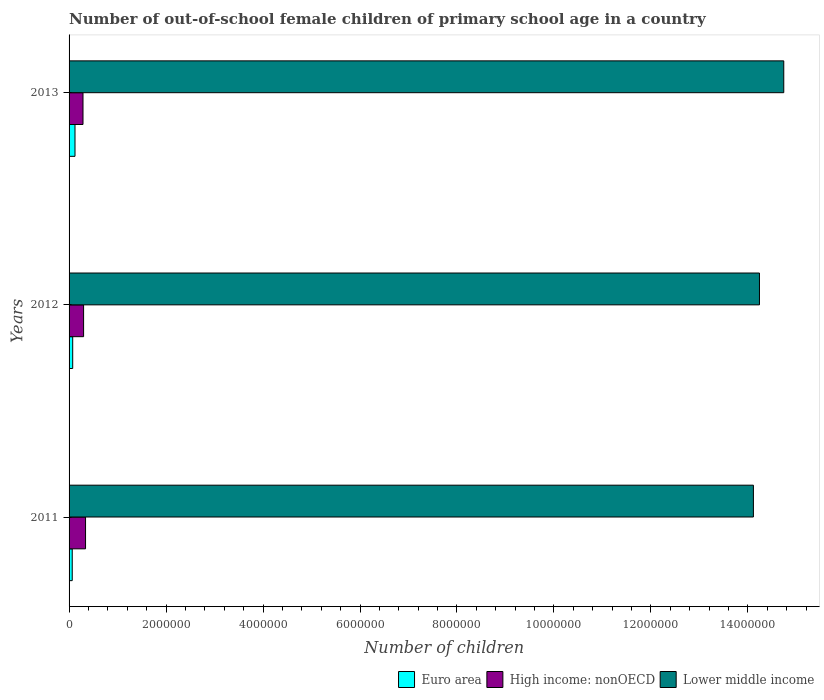How many different coloured bars are there?
Keep it short and to the point. 3. Are the number of bars per tick equal to the number of legend labels?
Your answer should be very brief. Yes. Are the number of bars on each tick of the Y-axis equal?
Ensure brevity in your answer.  Yes. How many bars are there on the 3rd tick from the top?
Your answer should be compact. 3. How many bars are there on the 3rd tick from the bottom?
Ensure brevity in your answer.  3. In how many cases, is the number of bars for a given year not equal to the number of legend labels?
Ensure brevity in your answer.  0. What is the number of out-of-school female children in Lower middle income in 2011?
Ensure brevity in your answer.  1.41e+07. Across all years, what is the maximum number of out-of-school female children in High income: nonOECD?
Your answer should be very brief. 3.40e+05. Across all years, what is the minimum number of out-of-school female children in Lower middle income?
Give a very brief answer. 1.41e+07. In which year was the number of out-of-school female children in Euro area minimum?
Provide a short and direct response. 2011. What is the total number of out-of-school female children in High income: nonOECD in the graph?
Offer a very short reply. 9.27e+05. What is the difference between the number of out-of-school female children in Lower middle income in 2011 and that in 2012?
Your response must be concise. -1.25e+05. What is the difference between the number of out-of-school female children in Euro area in 2011 and the number of out-of-school female children in High income: nonOECD in 2012?
Your response must be concise. -2.35e+05. What is the average number of out-of-school female children in High income: nonOECD per year?
Offer a very short reply. 3.09e+05. In the year 2012, what is the difference between the number of out-of-school female children in Euro area and number of out-of-school female children in Lower middle income?
Offer a very short reply. -1.42e+07. In how many years, is the number of out-of-school female children in Lower middle income greater than 6400000 ?
Make the answer very short. 3. What is the ratio of the number of out-of-school female children in Lower middle income in 2011 to that in 2012?
Offer a terse response. 0.99. Is the number of out-of-school female children in High income: nonOECD in 2011 less than that in 2012?
Offer a very short reply. No. Is the difference between the number of out-of-school female children in Euro area in 2012 and 2013 greater than the difference between the number of out-of-school female children in Lower middle income in 2012 and 2013?
Give a very brief answer. Yes. What is the difference between the highest and the second highest number of out-of-school female children in Lower middle income?
Your response must be concise. 5.01e+05. What is the difference between the highest and the lowest number of out-of-school female children in Lower middle income?
Your response must be concise. 6.26e+05. In how many years, is the number of out-of-school female children in Lower middle income greater than the average number of out-of-school female children in Lower middle income taken over all years?
Your response must be concise. 1. What does the 1st bar from the top in 2013 represents?
Keep it short and to the point. Lower middle income. What does the 1st bar from the bottom in 2012 represents?
Provide a succinct answer. Euro area. Is it the case that in every year, the sum of the number of out-of-school female children in High income: nonOECD and number of out-of-school female children in Euro area is greater than the number of out-of-school female children in Lower middle income?
Ensure brevity in your answer.  No. How many bars are there?
Your answer should be compact. 9. Are all the bars in the graph horizontal?
Provide a short and direct response. Yes. How many years are there in the graph?
Keep it short and to the point. 3. What is the difference between two consecutive major ticks on the X-axis?
Offer a very short reply. 2.00e+06. Does the graph contain any zero values?
Ensure brevity in your answer.  No. Does the graph contain grids?
Make the answer very short. No. How many legend labels are there?
Make the answer very short. 3. What is the title of the graph?
Give a very brief answer. Number of out-of-school female children of primary school age in a country. Does "Sweden" appear as one of the legend labels in the graph?
Offer a very short reply. No. What is the label or title of the X-axis?
Offer a terse response. Number of children. What is the Number of children in Euro area in 2011?
Offer a terse response. 6.51e+04. What is the Number of children of High income: nonOECD in 2011?
Provide a short and direct response. 3.40e+05. What is the Number of children in Lower middle income in 2011?
Your response must be concise. 1.41e+07. What is the Number of children of Euro area in 2012?
Your response must be concise. 7.48e+04. What is the Number of children in High income: nonOECD in 2012?
Provide a short and direct response. 3.00e+05. What is the Number of children in Lower middle income in 2012?
Offer a very short reply. 1.42e+07. What is the Number of children in Euro area in 2013?
Give a very brief answer. 1.22e+05. What is the Number of children of High income: nonOECD in 2013?
Ensure brevity in your answer.  2.87e+05. What is the Number of children in Lower middle income in 2013?
Offer a terse response. 1.47e+07. Across all years, what is the maximum Number of children in Euro area?
Provide a succinct answer. 1.22e+05. Across all years, what is the maximum Number of children in High income: nonOECD?
Provide a succinct answer. 3.40e+05. Across all years, what is the maximum Number of children of Lower middle income?
Offer a terse response. 1.47e+07. Across all years, what is the minimum Number of children of Euro area?
Your answer should be compact. 6.51e+04. Across all years, what is the minimum Number of children in High income: nonOECD?
Ensure brevity in your answer.  2.87e+05. Across all years, what is the minimum Number of children of Lower middle income?
Your answer should be compact. 1.41e+07. What is the total Number of children in Euro area in the graph?
Provide a short and direct response. 2.62e+05. What is the total Number of children in High income: nonOECD in the graph?
Give a very brief answer. 9.27e+05. What is the total Number of children in Lower middle income in the graph?
Your response must be concise. 4.31e+07. What is the difference between the Number of children in Euro area in 2011 and that in 2012?
Provide a short and direct response. -9737. What is the difference between the Number of children of High income: nonOECD in 2011 and that in 2012?
Make the answer very short. 4.00e+04. What is the difference between the Number of children in Lower middle income in 2011 and that in 2012?
Offer a very short reply. -1.25e+05. What is the difference between the Number of children in Euro area in 2011 and that in 2013?
Give a very brief answer. -5.72e+04. What is the difference between the Number of children in High income: nonOECD in 2011 and that in 2013?
Offer a terse response. 5.24e+04. What is the difference between the Number of children of Lower middle income in 2011 and that in 2013?
Keep it short and to the point. -6.26e+05. What is the difference between the Number of children of Euro area in 2012 and that in 2013?
Your response must be concise. -4.74e+04. What is the difference between the Number of children in High income: nonOECD in 2012 and that in 2013?
Give a very brief answer. 1.24e+04. What is the difference between the Number of children in Lower middle income in 2012 and that in 2013?
Give a very brief answer. -5.01e+05. What is the difference between the Number of children in Euro area in 2011 and the Number of children in High income: nonOECD in 2012?
Keep it short and to the point. -2.35e+05. What is the difference between the Number of children of Euro area in 2011 and the Number of children of Lower middle income in 2012?
Give a very brief answer. -1.42e+07. What is the difference between the Number of children of High income: nonOECD in 2011 and the Number of children of Lower middle income in 2012?
Give a very brief answer. -1.39e+07. What is the difference between the Number of children of Euro area in 2011 and the Number of children of High income: nonOECD in 2013?
Provide a short and direct response. -2.22e+05. What is the difference between the Number of children of Euro area in 2011 and the Number of children of Lower middle income in 2013?
Give a very brief answer. -1.47e+07. What is the difference between the Number of children of High income: nonOECD in 2011 and the Number of children of Lower middle income in 2013?
Provide a succinct answer. -1.44e+07. What is the difference between the Number of children in Euro area in 2012 and the Number of children in High income: nonOECD in 2013?
Your response must be concise. -2.12e+05. What is the difference between the Number of children in Euro area in 2012 and the Number of children in Lower middle income in 2013?
Your response must be concise. -1.47e+07. What is the difference between the Number of children of High income: nonOECD in 2012 and the Number of children of Lower middle income in 2013?
Provide a short and direct response. -1.44e+07. What is the average Number of children of Euro area per year?
Provide a short and direct response. 8.74e+04. What is the average Number of children in High income: nonOECD per year?
Offer a very short reply. 3.09e+05. What is the average Number of children in Lower middle income per year?
Your answer should be compact. 1.44e+07. In the year 2011, what is the difference between the Number of children of Euro area and Number of children of High income: nonOECD?
Make the answer very short. -2.75e+05. In the year 2011, what is the difference between the Number of children of Euro area and Number of children of Lower middle income?
Ensure brevity in your answer.  -1.40e+07. In the year 2011, what is the difference between the Number of children in High income: nonOECD and Number of children in Lower middle income?
Provide a succinct answer. -1.38e+07. In the year 2012, what is the difference between the Number of children in Euro area and Number of children in High income: nonOECD?
Make the answer very short. -2.25e+05. In the year 2012, what is the difference between the Number of children of Euro area and Number of children of Lower middle income?
Keep it short and to the point. -1.42e+07. In the year 2012, what is the difference between the Number of children of High income: nonOECD and Number of children of Lower middle income?
Offer a terse response. -1.39e+07. In the year 2013, what is the difference between the Number of children of Euro area and Number of children of High income: nonOECD?
Offer a terse response. -1.65e+05. In the year 2013, what is the difference between the Number of children of Euro area and Number of children of Lower middle income?
Offer a terse response. -1.46e+07. In the year 2013, what is the difference between the Number of children of High income: nonOECD and Number of children of Lower middle income?
Your answer should be very brief. -1.45e+07. What is the ratio of the Number of children of Euro area in 2011 to that in 2012?
Give a very brief answer. 0.87. What is the ratio of the Number of children in High income: nonOECD in 2011 to that in 2012?
Give a very brief answer. 1.13. What is the ratio of the Number of children of Lower middle income in 2011 to that in 2012?
Provide a succinct answer. 0.99. What is the ratio of the Number of children in Euro area in 2011 to that in 2013?
Ensure brevity in your answer.  0.53. What is the ratio of the Number of children in High income: nonOECD in 2011 to that in 2013?
Offer a terse response. 1.18. What is the ratio of the Number of children of Lower middle income in 2011 to that in 2013?
Make the answer very short. 0.96. What is the ratio of the Number of children in Euro area in 2012 to that in 2013?
Your answer should be very brief. 0.61. What is the ratio of the Number of children in High income: nonOECD in 2012 to that in 2013?
Offer a very short reply. 1.04. What is the ratio of the Number of children in Lower middle income in 2012 to that in 2013?
Provide a succinct answer. 0.97. What is the difference between the highest and the second highest Number of children in Euro area?
Keep it short and to the point. 4.74e+04. What is the difference between the highest and the second highest Number of children in High income: nonOECD?
Your answer should be compact. 4.00e+04. What is the difference between the highest and the second highest Number of children of Lower middle income?
Your response must be concise. 5.01e+05. What is the difference between the highest and the lowest Number of children in Euro area?
Your answer should be compact. 5.72e+04. What is the difference between the highest and the lowest Number of children in High income: nonOECD?
Give a very brief answer. 5.24e+04. What is the difference between the highest and the lowest Number of children in Lower middle income?
Your response must be concise. 6.26e+05. 